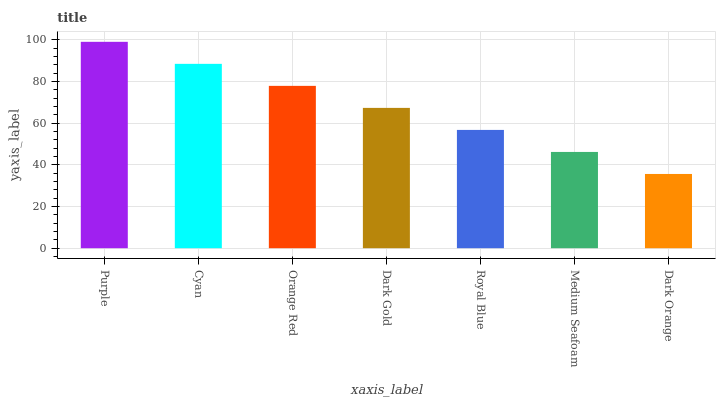Is Dark Orange the minimum?
Answer yes or no. Yes. Is Purple the maximum?
Answer yes or no. Yes. Is Cyan the minimum?
Answer yes or no. No. Is Cyan the maximum?
Answer yes or no. No. Is Purple greater than Cyan?
Answer yes or no. Yes. Is Cyan less than Purple?
Answer yes or no. Yes. Is Cyan greater than Purple?
Answer yes or no. No. Is Purple less than Cyan?
Answer yes or no. No. Is Dark Gold the high median?
Answer yes or no. Yes. Is Dark Gold the low median?
Answer yes or no. Yes. Is Royal Blue the high median?
Answer yes or no. No. Is Purple the low median?
Answer yes or no. No. 